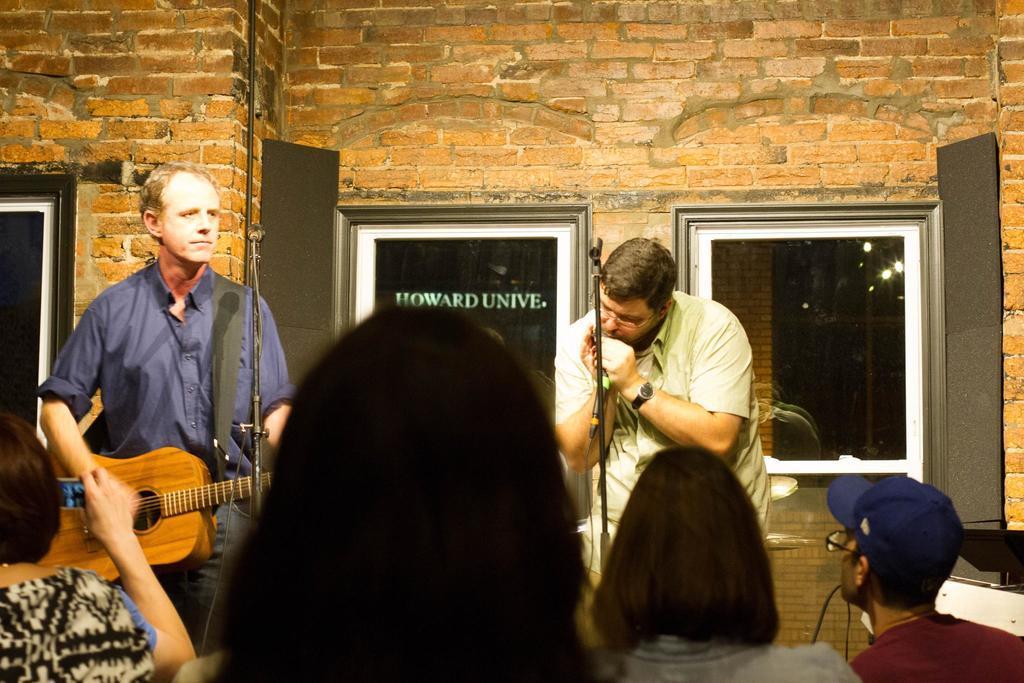Could you give a brief overview of what you see in this image? there are 4 people watching 2 people playing musical instruments. the person at the left is wearing a blue shirt and playing guitar. the person at the right is playing a musical instrument. behind them there is a brick wall on which there are 2 glass windows. 